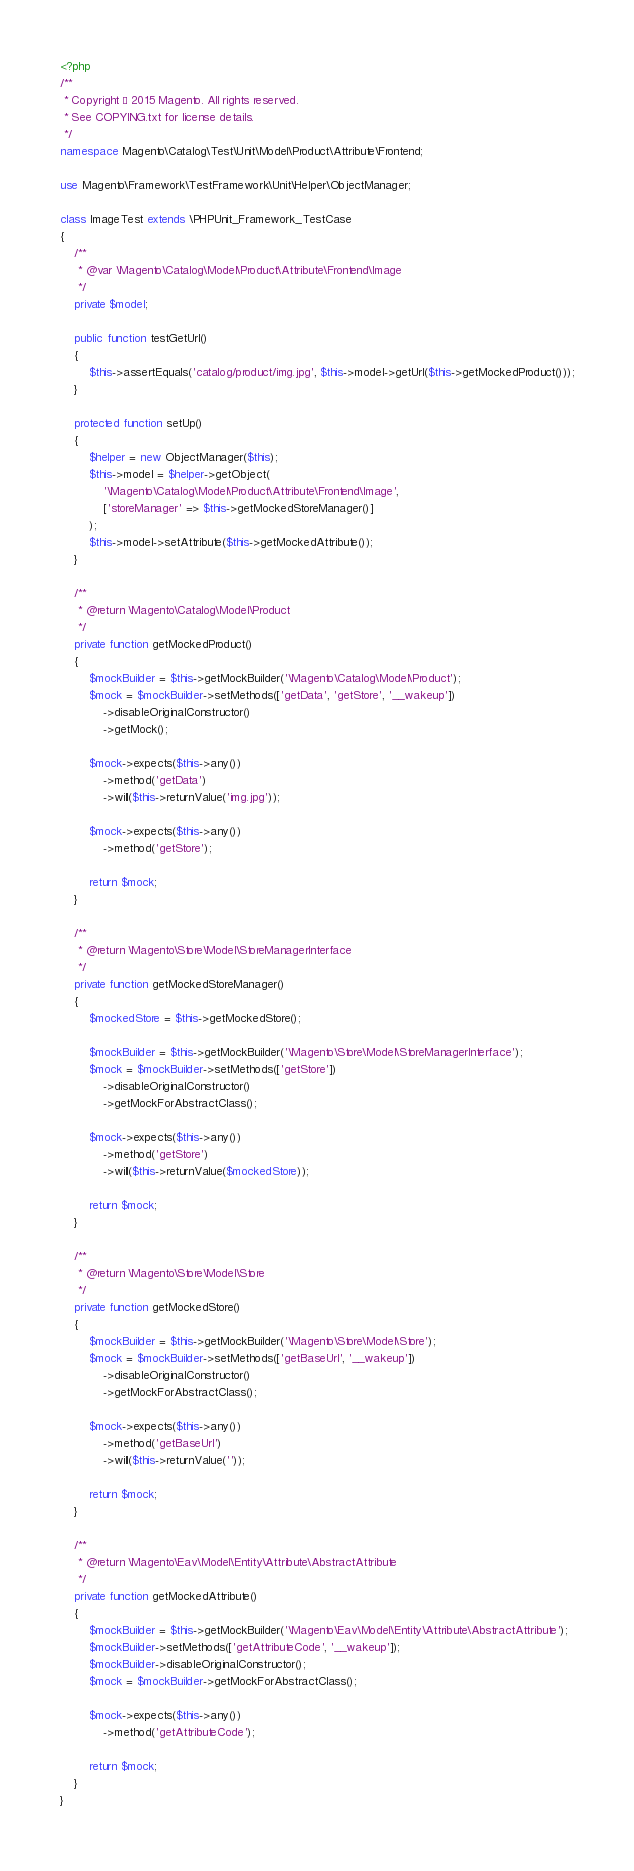<code> <loc_0><loc_0><loc_500><loc_500><_PHP_><?php
/**
 * Copyright © 2015 Magento. All rights reserved.
 * See COPYING.txt for license details.
 */
namespace Magento\Catalog\Test\Unit\Model\Product\Attribute\Frontend;

use Magento\Framework\TestFramework\Unit\Helper\ObjectManager;

class ImageTest extends \PHPUnit_Framework_TestCase
{
    /**
     * @var \Magento\Catalog\Model\Product\Attribute\Frontend\Image
     */
    private $model;

    public function testGetUrl()
    {
        $this->assertEquals('catalog/product/img.jpg', $this->model->getUrl($this->getMockedProduct()));
    }

    protected function setUp()
    {
        $helper = new ObjectManager($this);
        $this->model = $helper->getObject(
            '\Magento\Catalog\Model\Product\Attribute\Frontend\Image',
            ['storeManager' => $this->getMockedStoreManager()]
        );
        $this->model->setAttribute($this->getMockedAttribute());
    }

    /**
     * @return \Magento\Catalog\Model\Product
     */
    private function getMockedProduct()
    {
        $mockBuilder = $this->getMockBuilder('\Magento\Catalog\Model\Product');
        $mock = $mockBuilder->setMethods(['getData', 'getStore', '__wakeup'])
            ->disableOriginalConstructor()
            ->getMock();

        $mock->expects($this->any())
            ->method('getData')
            ->will($this->returnValue('img.jpg'));

        $mock->expects($this->any())
            ->method('getStore');

        return $mock;
    }

    /**
     * @return \Magento\Store\Model\StoreManagerInterface
     */
    private function getMockedStoreManager()
    {
        $mockedStore = $this->getMockedStore();

        $mockBuilder = $this->getMockBuilder('\Magento\Store\Model\StoreManagerInterface');
        $mock = $mockBuilder->setMethods(['getStore'])
            ->disableOriginalConstructor()
            ->getMockForAbstractClass();

        $mock->expects($this->any())
            ->method('getStore')
            ->will($this->returnValue($mockedStore));

        return $mock;
    }

    /**
     * @return \Magento\Store\Model\Store
     */
    private function getMockedStore()
    {
        $mockBuilder = $this->getMockBuilder('\Magento\Store\Model\Store');
        $mock = $mockBuilder->setMethods(['getBaseUrl', '__wakeup'])
            ->disableOriginalConstructor()
            ->getMockForAbstractClass();

        $mock->expects($this->any())
            ->method('getBaseUrl')
            ->will($this->returnValue(''));

        return $mock;
    }

    /**
     * @return \Magento\Eav\Model\Entity\Attribute\AbstractAttribute
     */
    private function getMockedAttribute()
    {
        $mockBuilder = $this->getMockBuilder('\Magento\Eav\Model\Entity\Attribute\AbstractAttribute');
        $mockBuilder->setMethods(['getAttributeCode', '__wakeup']);
        $mockBuilder->disableOriginalConstructor();
        $mock = $mockBuilder->getMockForAbstractClass();

        $mock->expects($this->any())
            ->method('getAttributeCode');

        return $mock;
    }
}
</code> 